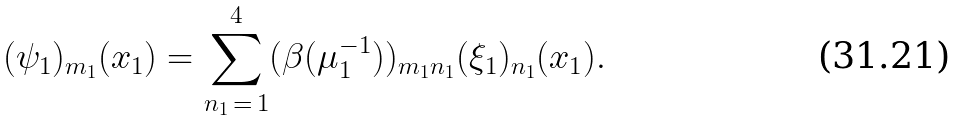Convert formula to latex. <formula><loc_0><loc_0><loc_500><loc_500>( \psi _ { 1 } ) _ { m _ { 1 } } ( x _ { 1 } ) = \sum _ { n _ { 1 } \, = \, 1 } ^ { 4 } ( \beta ( \mu _ { 1 } ^ { - 1 } ) ) _ { m _ { 1 } n _ { 1 } } ( \xi _ { 1 } ) _ { n _ { 1 } } ( x _ { 1 } ) .</formula> 